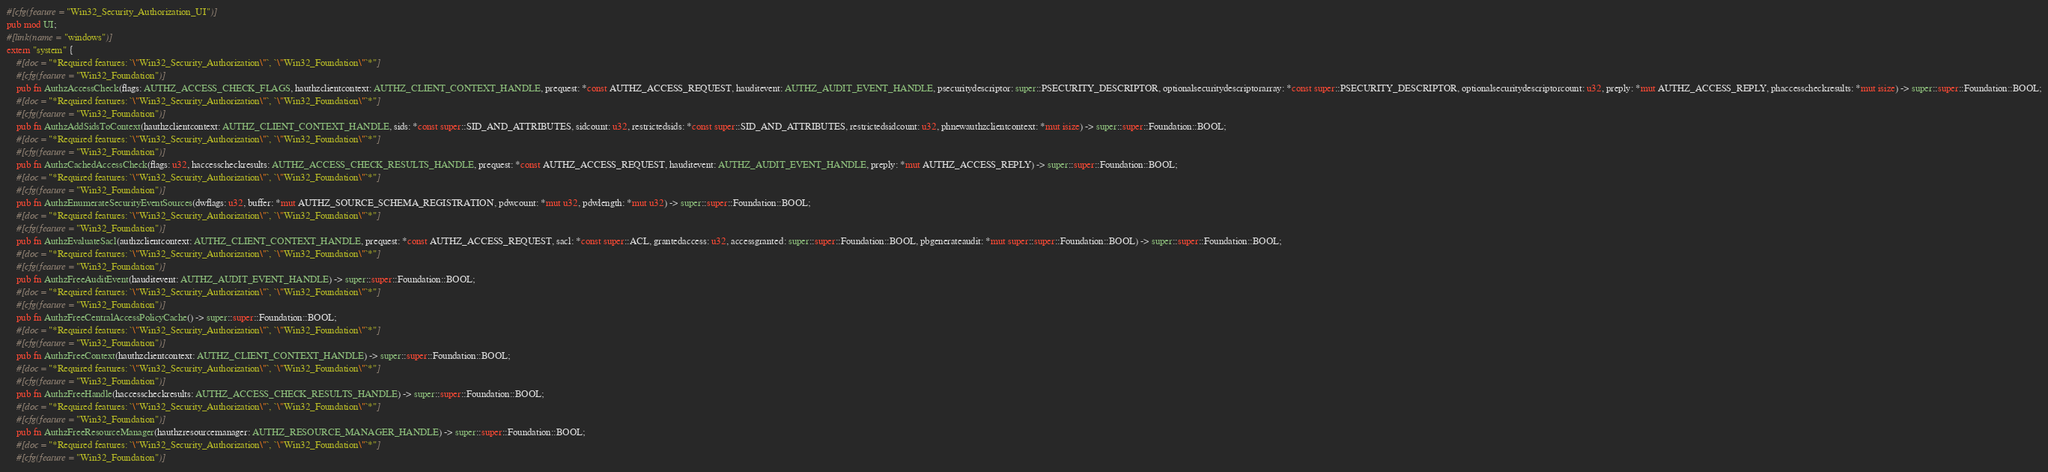Convert code to text. <code><loc_0><loc_0><loc_500><loc_500><_Rust_>#[cfg(feature = "Win32_Security_Authorization_UI")]
pub mod UI;
#[link(name = "windows")]
extern "system" {
    #[doc = "*Required features: `\"Win32_Security_Authorization\"`, `\"Win32_Foundation\"`*"]
    #[cfg(feature = "Win32_Foundation")]
    pub fn AuthzAccessCheck(flags: AUTHZ_ACCESS_CHECK_FLAGS, hauthzclientcontext: AUTHZ_CLIENT_CONTEXT_HANDLE, prequest: *const AUTHZ_ACCESS_REQUEST, hauditevent: AUTHZ_AUDIT_EVENT_HANDLE, psecuritydescriptor: super::PSECURITY_DESCRIPTOR, optionalsecuritydescriptorarray: *const super::PSECURITY_DESCRIPTOR, optionalsecuritydescriptorcount: u32, preply: *mut AUTHZ_ACCESS_REPLY, phaccesscheckresults: *mut isize) -> super::super::Foundation::BOOL;
    #[doc = "*Required features: `\"Win32_Security_Authorization\"`, `\"Win32_Foundation\"`*"]
    #[cfg(feature = "Win32_Foundation")]
    pub fn AuthzAddSidsToContext(hauthzclientcontext: AUTHZ_CLIENT_CONTEXT_HANDLE, sids: *const super::SID_AND_ATTRIBUTES, sidcount: u32, restrictedsids: *const super::SID_AND_ATTRIBUTES, restrictedsidcount: u32, phnewauthzclientcontext: *mut isize) -> super::super::Foundation::BOOL;
    #[doc = "*Required features: `\"Win32_Security_Authorization\"`, `\"Win32_Foundation\"`*"]
    #[cfg(feature = "Win32_Foundation")]
    pub fn AuthzCachedAccessCheck(flags: u32, haccesscheckresults: AUTHZ_ACCESS_CHECK_RESULTS_HANDLE, prequest: *const AUTHZ_ACCESS_REQUEST, hauditevent: AUTHZ_AUDIT_EVENT_HANDLE, preply: *mut AUTHZ_ACCESS_REPLY) -> super::super::Foundation::BOOL;
    #[doc = "*Required features: `\"Win32_Security_Authorization\"`, `\"Win32_Foundation\"`*"]
    #[cfg(feature = "Win32_Foundation")]
    pub fn AuthzEnumerateSecurityEventSources(dwflags: u32, buffer: *mut AUTHZ_SOURCE_SCHEMA_REGISTRATION, pdwcount: *mut u32, pdwlength: *mut u32) -> super::super::Foundation::BOOL;
    #[doc = "*Required features: `\"Win32_Security_Authorization\"`, `\"Win32_Foundation\"`*"]
    #[cfg(feature = "Win32_Foundation")]
    pub fn AuthzEvaluateSacl(authzclientcontext: AUTHZ_CLIENT_CONTEXT_HANDLE, prequest: *const AUTHZ_ACCESS_REQUEST, sacl: *const super::ACL, grantedaccess: u32, accessgranted: super::super::Foundation::BOOL, pbgenerateaudit: *mut super::super::Foundation::BOOL) -> super::super::Foundation::BOOL;
    #[doc = "*Required features: `\"Win32_Security_Authorization\"`, `\"Win32_Foundation\"`*"]
    #[cfg(feature = "Win32_Foundation")]
    pub fn AuthzFreeAuditEvent(hauditevent: AUTHZ_AUDIT_EVENT_HANDLE) -> super::super::Foundation::BOOL;
    #[doc = "*Required features: `\"Win32_Security_Authorization\"`, `\"Win32_Foundation\"`*"]
    #[cfg(feature = "Win32_Foundation")]
    pub fn AuthzFreeCentralAccessPolicyCache() -> super::super::Foundation::BOOL;
    #[doc = "*Required features: `\"Win32_Security_Authorization\"`, `\"Win32_Foundation\"`*"]
    #[cfg(feature = "Win32_Foundation")]
    pub fn AuthzFreeContext(hauthzclientcontext: AUTHZ_CLIENT_CONTEXT_HANDLE) -> super::super::Foundation::BOOL;
    #[doc = "*Required features: `\"Win32_Security_Authorization\"`, `\"Win32_Foundation\"`*"]
    #[cfg(feature = "Win32_Foundation")]
    pub fn AuthzFreeHandle(haccesscheckresults: AUTHZ_ACCESS_CHECK_RESULTS_HANDLE) -> super::super::Foundation::BOOL;
    #[doc = "*Required features: `\"Win32_Security_Authorization\"`, `\"Win32_Foundation\"`*"]
    #[cfg(feature = "Win32_Foundation")]
    pub fn AuthzFreeResourceManager(hauthzresourcemanager: AUTHZ_RESOURCE_MANAGER_HANDLE) -> super::super::Foundation::BOOL;
    #[doc = "*Required features: `\"Win32_Security_Authorization\"`, `\"Win32_Foundation\"`*"]
    #[cfg(feature = "Win32_Foundation")]</code> 